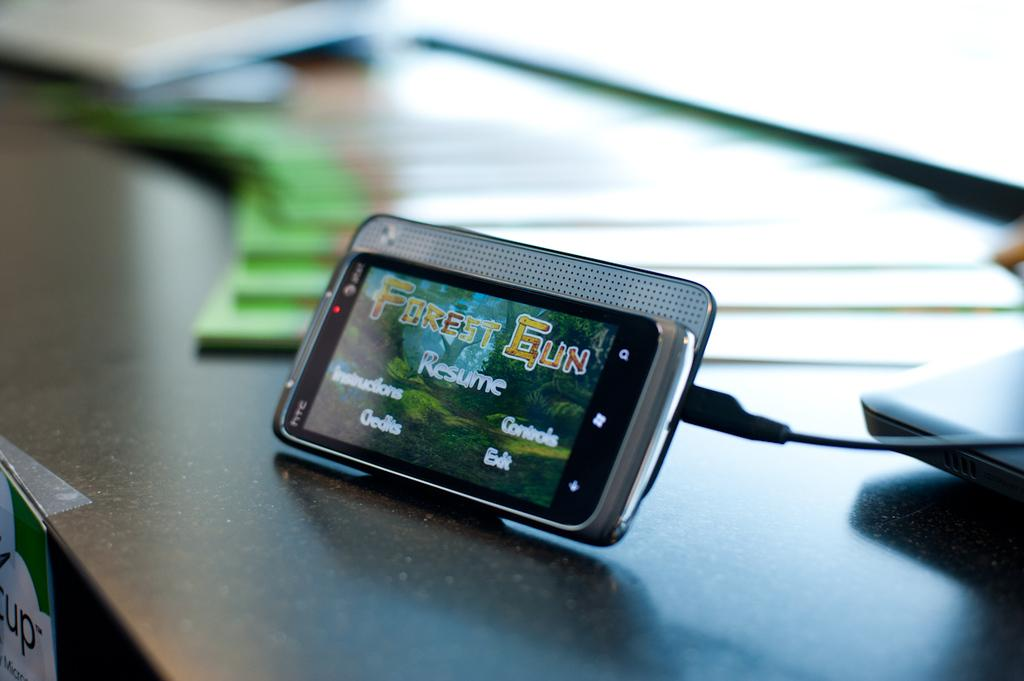<image>
Describe the image concisely. htc phone sitting at an angle with forest gun game on the screen 